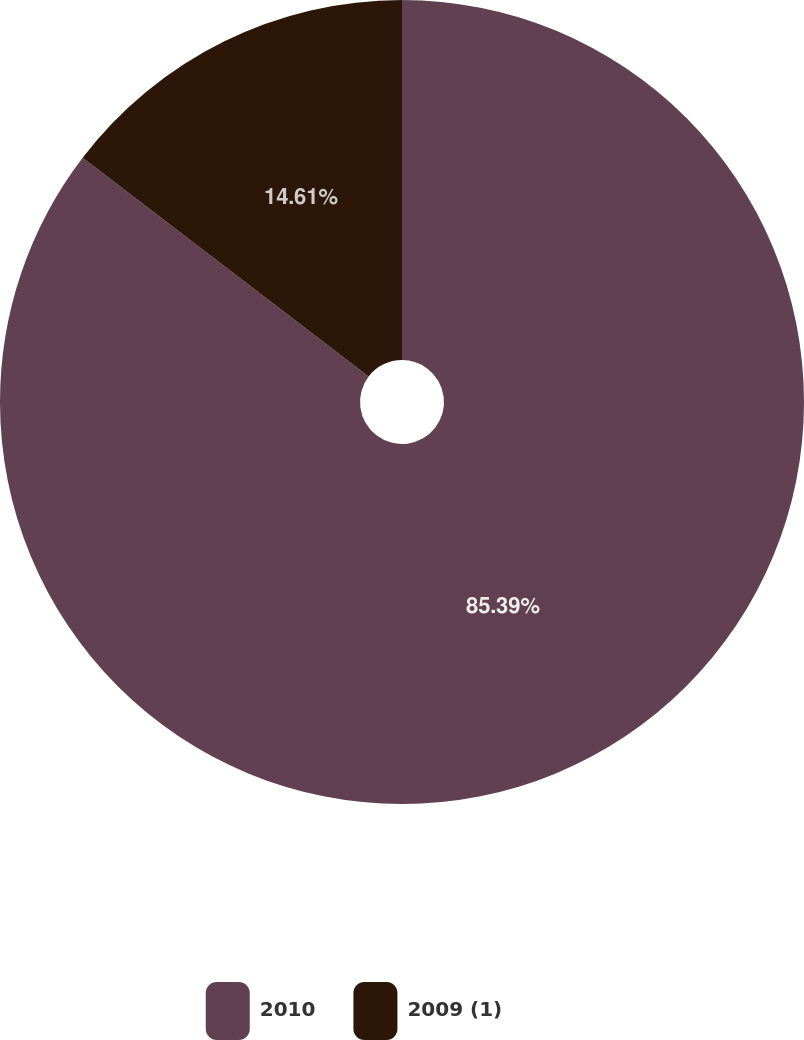Convert chart to OTSL. <chart><loc_0><loc_0><loc_500><loc_500><pie_chart><fcel>2010<fcel>2009 (1)<nl><fcel>85.39%<fcel>14.61%<nl></chart> 